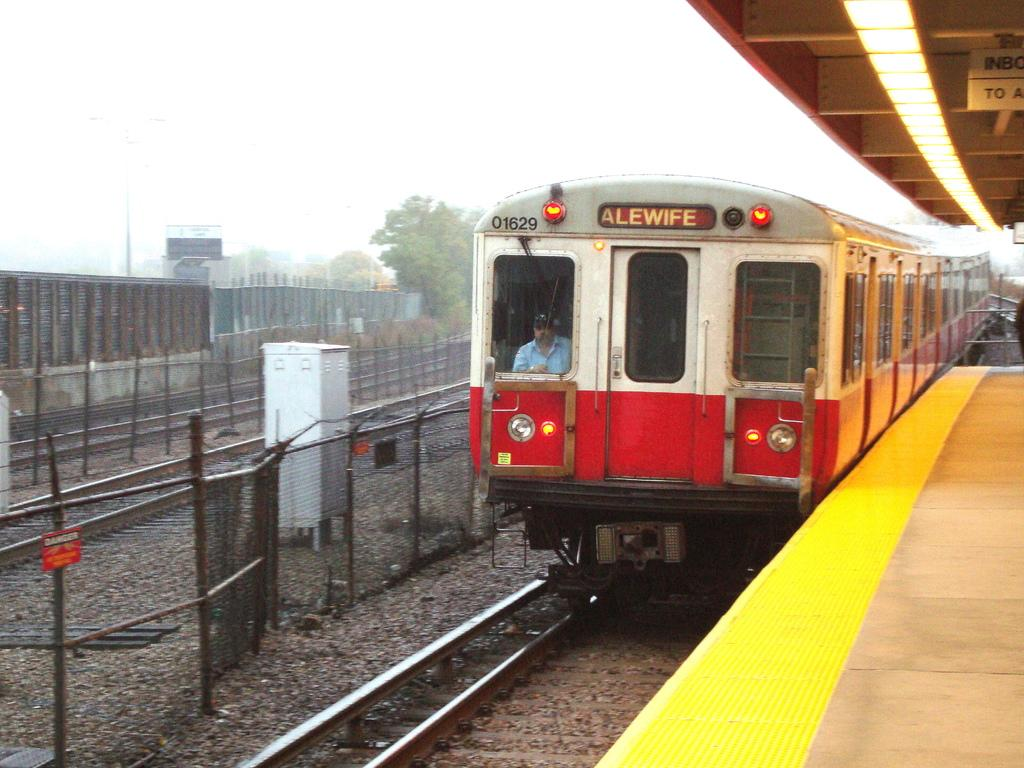<image>
Write a terse but informative summary of the picture. A train with the destination Alewife on its display pulls into station. 